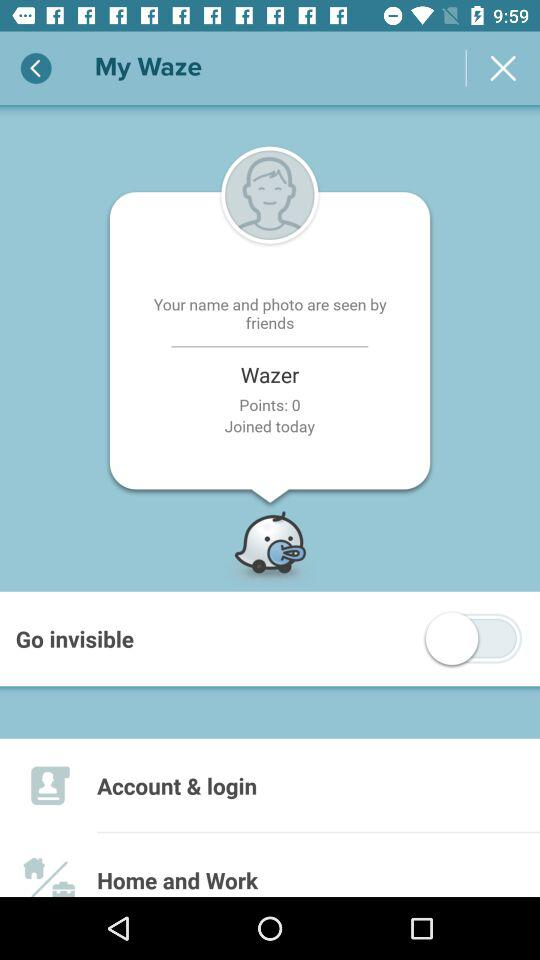Who can see the name and photograph? The name and photograph can be seen by friends. 